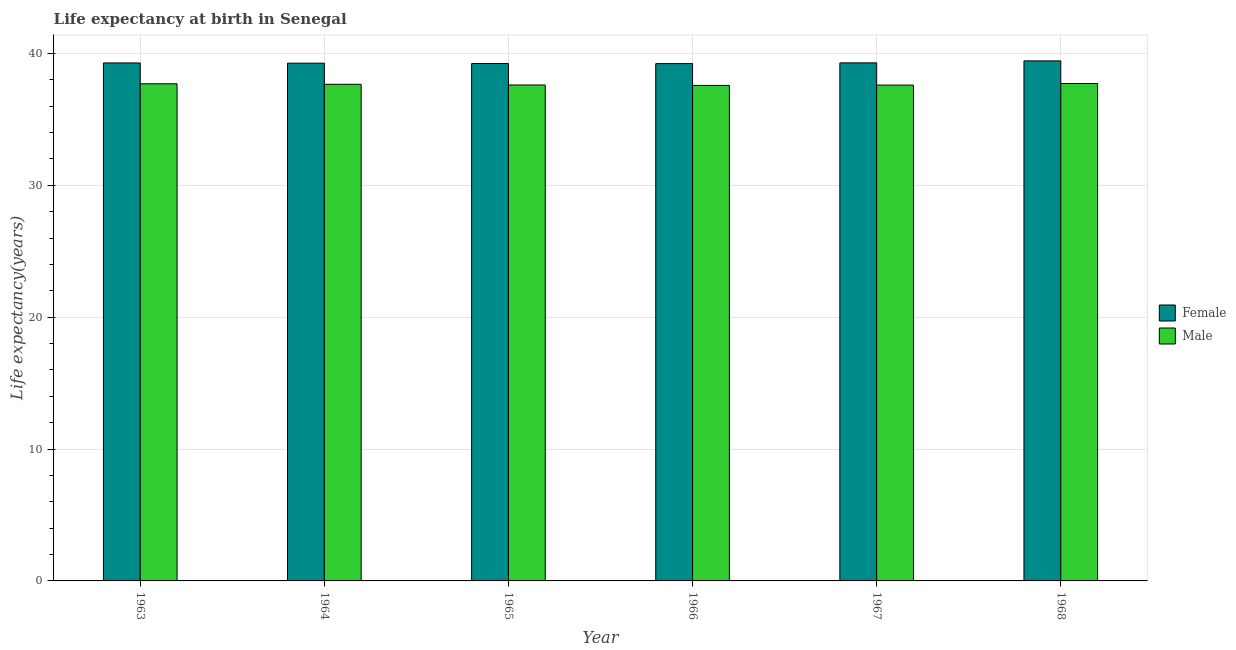Are the number of bars on each tick of the X-axis equal?
Provide a succinct answer. Yes. How many bars are there on the 2nd tick from the left?
Your answer should be very brief. 2. How many bars are there on the 4th tick from the right?
Provide a succinct answer. 2. What is the label of the 5th group of bars from the left?
Offer a terse response. 1967. In how many cases, is the number of bars for a given year not equal to the number of legend labels?
Offer a very short reply. 0. What is the life expectancy(female) in 1964?
Keep it short and to the point. 39.26. Across all years, what is the maximum life expectancy(female)?
Provide a short and direct response. 39.43. Across all years, what is the minimum life expectancy(female)?
Ensure brevity in your answer.  39.22. In which year was the life expectancy(female) maximum?
Your response must be concise. 1968. In which year was the life expectancy(male) minimum?
Provide a succinct answer. 1966. What is the total life expectancy(female) in the graph?
Your answer should be very brief. 235.69. What is the difference between the life expectancy(female) in 1966 and that in 1968?
Your response must be concise. -0.21. What is the difference between the life expectancy(male) in 1963 and the life expectancy(female) in 1967?
Your response must be concise. 0.1. What is the average life expectancy(male) per year?
Your answer should be compact. 37.64. In the year 1963, what is the difference between the life expectancy(male) and life expectancy(female)?
Keep it short and to the point. 0. In how many years, is the life expectancy(male) greater than 8 years?
Your answer should be compact. 6. What is the ratio of the life expectancy(male) in 1963 to that in 1968?
Make the answer very short. 1. Is the life expectancy(male) in 1963 less than that in 1965?
Give a very brief answer. No. Is the difference between the life expectancy(female) in 1967 and 1968 greater than the difference between the life expectancy(male) in 1967 and 1968?
Ensure brevity in your answer.  No. What is the difference between the highest and the second highest life expectancy(female)?
Offer a very short reply. 0.15. What is the difference between the highest and the lowest life expectancy(male)?
Make the answer very short. 0.14. In how many years, is the life expectancy(male) greater than the average life expectancy(male) taken over all years?
Provide a succinct answer. 3. Is the sum of the life expectancy(male) in 1963 and 1968 greater than the maximum life expectancy(female) across all years?
Give a very brief answer. Yes. What does the 2nd bar from the left in 1968 represents?
Your response must be concise. Male. What does the 2nd bar from the right in 1964 represents?
Provide a succinct answer. Female. How many bars are there?
Provide a short and direct response. 12. How many years are there in the graph?
Offer a terse response. 6. What is the difference between two consecutive major ticks on the Y-axis?
Ensure brevity in your answer.  10. Are the values on the major ticks of Y-axis written in scientific E-notation?
Offer a terse response. No. Where does the legend appear in the graph?
Provide a short and direct response. Center right. How many legend labels are there?
Your answer should be compact. 2. What is the title of the graph?
Give a very brief answer. Life expectancy at birth in Senegal. Does "Number of arrivals" appear as one of the legend labels in the graph?
Provide a short and direct response. No. What is the label or title of the Y-axis?
Provide a succinct answer. Life expectancy(years). What is the Life expectancy(years) of Female in 1963?
Provide a short and direct response. 39.27. What is the Life expectancy(years) in Male in 1963?
Provide a succinct answer. 37.69. What is the Life expectancy(years) of Female in 1964?
Ensure brevity in your answer.  39.26. What is the Life expectancy(years) of Male in 1964?
Your response must be concise. 37.66. What is the Life expectancy(years) in Female in 1965?
Make the answer very short. 39.23. What is the Life expectancy(years) in Male in 1965?
Your response must be concise. 37.6. What is the Life expectancy(years) in Female in 1966?
Provide a succinct answer. 39.22. What is the Life expectancy(years) of Male in 1966?
Offer a terse response. 37.57. What is the Life expectancy(years) in Female in 1967?
Ensure brevity in your answer.  39.28. What is the Life expectancy(years) of Male in 1967?
Keep it short and to the point. 37.59. What is the Life expectancy(years) in Female in 1968?
Your answer should be compact. 39.43. What is the Life expectancy(years) in Male in 1968?
Provide a short and direct response. 37.71. Across all years, what is the maximum Life expectancy(years) in Female?
Provide a short and direct response. 39.43. Across all years, what is the maximum Life expectancy(years) of Male?
Your answer should be compact. 37.71. Across all years, what is the minimum Life expectancy(years) of Female?
Your answer should be very brief. 39.22. Across all years, what is the minimum Life expectancy(years) of Male?
Provide a succinct answer. 37.57. What is the total Life expectancy(years) in Female in the graph?
Give a very brief answer. 235.69. What is the total Life expectancy(years) in Male in the graph?
Your response must be concise. 225.83. What is the difference between the Life expectancy(years) of Female in 1963 and that in 1964?
Your answer should be very brief. 0.02. What is the difference between the Life expectancy(years) of Male in 1963 and that in 1964?
Make the answer very short. 0.04. What is the difference between the Life expectancy(years) of Female in 1963 and that in 1965?
Your answer should be very brief. 0.04. What is the difference between the Life expectancy(years) of Male in 1963 and that in 1965?
Provide a short and direct response. 0.09. What is the difference between the Life expectancy(years) in Male in 1963 and that in 1966?
Give a very brief answer. 0.12. What is the difference between the Life expectancy(years) in Female in 1963 and that in 1967?
Your answer should be very brief. -0.01. What is the difference between the Life expectancy(years) of Male in 1963 and that in 1967?
Provide a succinct answer. 0.1. What is the difference between the Life expectancy(years) of Female in 1963 and that in 1968?
Offer a terse response. -0.16. What is the difference between the Life expectancy(years) of Male in 1963 and that in 1968?
Keep it short and to the point. -0.02. What is the difference between the Life expectancy(years) of Female in 1964 and that in 1965?
Keep it short and to the point. 0.03. What is the difference between the Life expectancy(years) in Male in 1964 and that in 1965?
Make the answer very short. 0.05. What is the difference between the Life expectancy(years) in Female in 1964 and that in 1966?
Your answer should be compact. 0.03. What is the difference between the Life expectancy(years) in Male in 1964 and that in 1966?
Provide a succinct answer. 0.09. What is the difference between the Life expectancy(years) in Female in 1964 and that in 1967?
Offer a very short reply. -0.02. What is the difference between the Life expectancy(years) in Female in 1964 and that in 1968?
Give a very brief answer. -0.17. What is the difference between the Life expectancy(years) of Male in 1964 and that in 1968?
Give a very brief answer. -0.06. What is the difference between the Life expectancy(years) in Female in 1965 and that in 1966?
Provide a succinct answer. 0.01. What is the difference between the Life expectancy(years) of Male in 1965 and that in 1966?
Ensure brevity in your answer.  0.03. What is the difference between the Life expectancy(years) of Female in 1965 and that in 1967?
Offer a terse response. -0.05. What is the difference between the Life expectancy(years) of Male in 1965 and that in 1967?
Your response must be concise. 0.01. What is the difference between the Life expectancy(years) in Female in 1965 and that in 1968?
Keep it short and to the point. -0.2. What is the difference between the Life expectancy(years) of Male in 1965 and that in 1968?
Ensure brevity in your answer.  -0.11. What is the difference between the Life expectancy(years) in Female in 1966 and that in 1967?
Keep it short and to the point. -0.06. What is the difference between the Life expectancy(years) of Male in 1966 and that in 1967?
Ensure brevity in your answer.  -0.03. What is the difference between the Life expectancy(years) of Female in 1966 and that in 1968?
Ensure brevity in your answer.  -0.21. What is the difference between the Life expectancy(years) in Male in 1966 and that in 1968?
Provide a short and direct response. -0.14. What is the difference between the Life expectancy(years) of Female in 1967 and that in 1968?
Your answer should be very brief. -0.15. What is the difference between the Life expectancy(years) in Male in 1967 and that in 1968?
Give a very brief answer. -0.12. What is the difference between the Life expectancy(years) in Female in 1963 and the Life expectancy(years) in Male in 1964?
Ensure brevity in your answer.  1.62. What is the difference between the Life expectancy(years) in Female in 1963 and the Life expectancy(years) in Male in 1965?
Provide a succinct answer. 1.67. What is the difference between the Life expectancy(years) in Female in 1963 and the Life expectancy(years) in Male in 1966?
Provide a succinct answer. 1.7. What is the difference between the Life expectancy(years) in Female in 1963 and the Life expectancy(years) in Male in 1967?
Ensure brevity in your answer.  1.68. What is the difference between the Life expectancy(years) of Female in 1963 and the Life expectancy(years) of Male in 1968?
Offer a terse response. 1.56. What is the difference between the Life expectancy(years) of Female in 1964 and the Life expectancy(years) of Male in 1965?
Ensure brevity in your answer.  1.65. What is the difference between the Life expectancy(years) in Female in 1964 and the Life expectancy(years) in Male in 1966?
Your response must be concise. 1.69. What is the difference between the Life expectancy(years) of Female in 1964 and the Life expectancy(years) of Male in 1967?
Your response must be concise. 1.66. What is the difference between the Life expectancy(years) of Female in 1964 and the Life expectancy(years) of Male in 1968?
Ensure brevity in your answer.  1.54. What is the difference between the Life expectancy(years) in Female in 1965 and the Life expectancy(years) in Male in 1966?
Your response must be concise. 1.66. What is the difference between the Life expectancy(years) of Female in 1965 and the Life expectancy(years) of Male in 1967?
Provide a succinct answer. 1.63. What is the difference between the Life expectancy(years) of Female in 1965 and the Life expectancy(years) of Male in 1968?
Your response must be concise. 1.51. What is the difference between the Life expectancy(years) in Female in 1966 and the Life expectancy(years) in Male in 1967?
Make the answer very short. 1.63. What is the difference between the Life expectancy(years) in Female in 1966 and the Life expectancy(years) in Male in 1968?
Your answer should be very brief. 1.51. What is the difference between the Life expectancy(years) in Female in 1967 and the Life expectancy(years) in Male in 1968?
Your answer should be very brief. 1.56. What is the average Life expectancy(years) in Female per year?
Offer a terse response. 39.28. What is the average Life expectancy(years) in Male per year?
Provide a succinct answer. 37.64. In the year 1963, what is the difference between the Life expectancy(years) of Female and Life expectancy(years) of Male?
Keep it short and to the point. 1.58. In the year 1964, what is the difference between the Life expectancy(years) in Female and Life expectancy(years) in Male?
Provide a short and direct response. 1.6. In the year 1965, what is the difference between the Life expectancy(years) in Female and Life expectancy(years) in Male?
Provide a succinct answer. 1.62. In the year 1966, what is the difference between the Life expectancy(years) in Female and Life expectancy(years) in Male?
Keep it short and to the point. 1.65. In the year 1967, what is the difference between the Life expectancy(years) in Female and Life expectancy(years) in Male?
Make the answer very short. 1.68. In the year 1968, what is the difference between the Life expectancy(years) of Female and Life expectancy(years) of Male?
Your response must be concise. 1.72. What is the ratio of the Life expectancy(years) in Male in 1963 to that in 1966?
Make the answer very short. 1. What is the ratio of the Life expectancy(years) of Female in 1963 to that in 1967?
Offer a terse response. 1. What is the ratio of the Life expectancy(years) in Male in 1963 to that in 1967?
Your answer should be compact. 1. What is the ratio of the Life expectancy(years) in Female in 1963 to that in 1968?
Make the answer very short. 1. What is the ratio of the Life expectancy(years) in Male in 1963 to that in 1968?
Offer a very short reply. 1. What is the ratio of the Life expectancy(years) in Female in 1964 to that in 1965?
Give a very brief answer. 1. What is the ratio of the Life expectancy(years) in Female in 1964 to that in 1966?
Give a very brief answer. 1. What is the ratio of the Life expectancy(years) in Male in 1964 to that in 1967?
Provide a succinct answer. 1. What is the ratio of the Life expectancy(years) in Male in 1964 to that in 1968?
Provide a succinct answer. 1. What is the ratio of the Life expectancy(years) in Female in 1965 to that in 1966?
Give a very brief answer. 1. What is the ratio of the Life expectancy(years) in Female in 1965 to that in 1968?
Keep it short and to the point. 0.99. What is the ratio of the Life expectancy(years) of Male in 1965 to that in 1968?
Your answer should be compact. 1. What is the ratio of the Life expectancy(years) in Male in 1966 to that in 1967?
Ensure brevity in your answer.  1. What is the ratio of the Life expectancy(years) in Female in 1966 to that in 1968?
Keep it short and to the point. 0.99. What is the ratio of the Life expectancy(years) of Female in 1967 to that in 1968?
Provide a succinct answer. 1. What is the ratio of the Life expectancy(years) in Male in 1967 to that in 1968?
Offer a very short reply. 1. What is the difference between the highest and the second highest Life expectancy(years) of Female?
Your response must be concise. 0.15. What is the difference between the highest and the lowest Life expectancy(years) in Female?
Ensure brevity in your answer.  0.21. What is the difference between the highest and the lowest Life expectancy(years) of Male?
Provide a succinct answer. 0.14. 